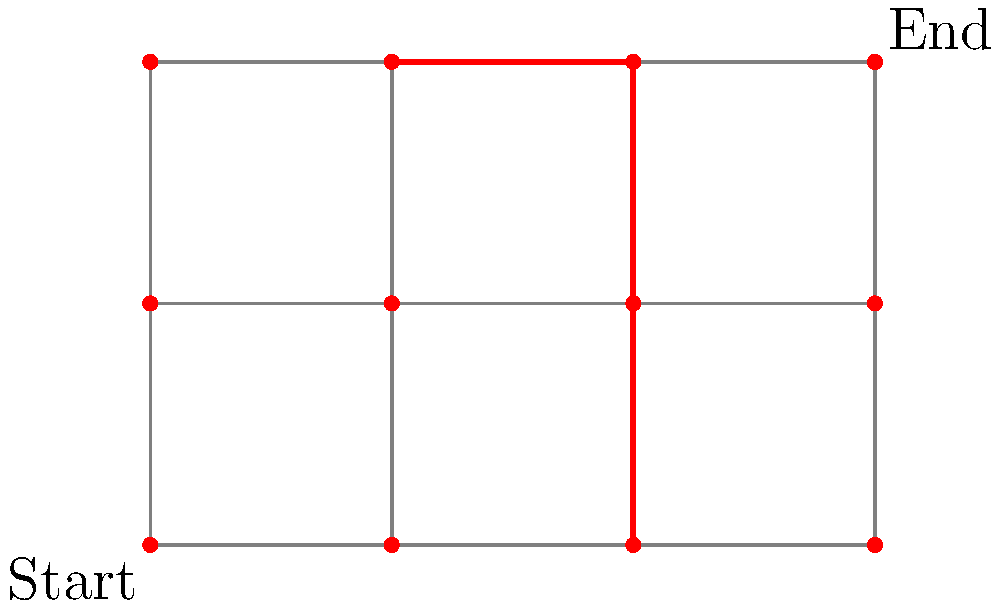In a maze-based game, players navigate from the Start to the End point. Each intersection allows movement in any connected direction with equal probability. Dead ends force players to backtrack. What is the probability of a player reaching the End point without backtracking? To solve this probability puzzle, we'll follow these steps:

1) First, we need to identify the possible paths from Start to End without backtracking. There is only one such path: (0,0) → (1,0) → (2,0) → (2,1) → (2,2) → (3,2).

2) Now, we'll calculate the probability of choosing this exact path:

   a) At (0,0), there are 2 choices, and the probability of choosing the correct one is 1/2.
   b) At (1,0), there are 3 choices, and the probability is 1/3.
   c) At (2,0), there are 3 choices, and the probability is 1/3.
   d) At (2,1), there are 3 choices, and the probability is 1/3.
   e) At (2,2), there are 2 choices, and the probability is 1/2.

3) The overall probability is the product of these individual probabilities:

   $$P(\text{correct path}) = \frac{1}{2} \times \frac{1}{3} \times \frac{1}{3} \times \frac{1}{3} \times \frac{1}{2}$$

4) Simplifying:

   $$P(\text{correct path}) = \frac{1}{108}$$

Therefore, the probability of a player reaching the End point without backtracking is 1/108.
Answer: 1/108 